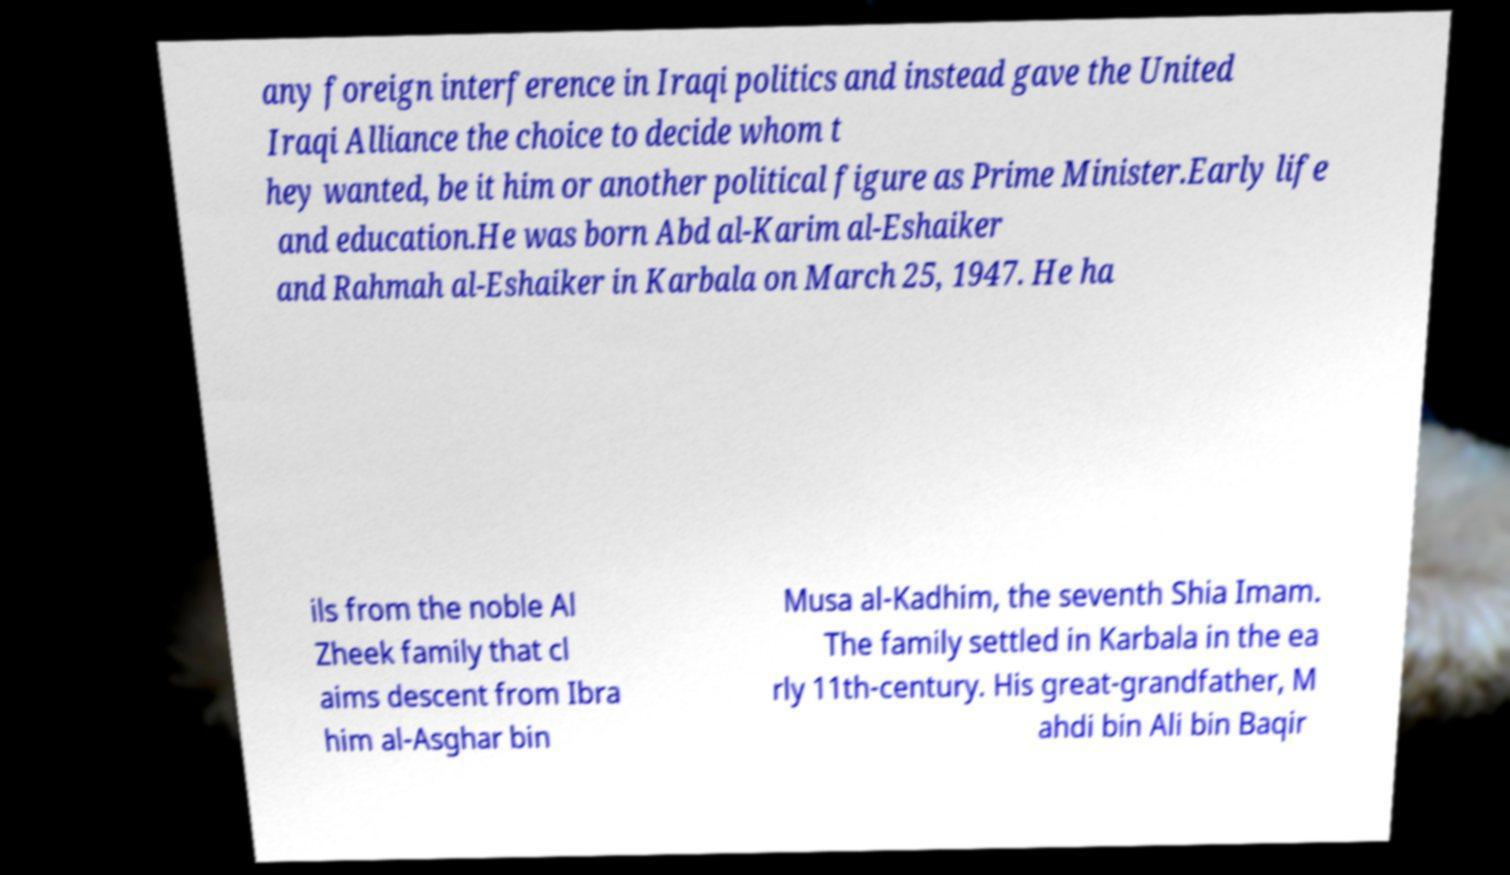Could you assist in decoding the text presented in this image and type it out clearly? any foreign interference in Iraqi politics and instead gave the United Iraqi Alliance the choice to decide whom t hey wanted, be it him or another political figure as Prime Minister.Early life and education.He was born Abd al-Karim al-Eshaiker and Rahmah al-Eshaiker in Karbala on March 25, 1947. He ha ils from the noble Al Zheek family that cl aims descent from Ibra him al-Asghar bin Musa al-Kadhim, the seventh Shia Imam. The family settled in Karbala in the ea rly 11th-century. His great-grandfather, M ahdi bin Ali bin Baqir 